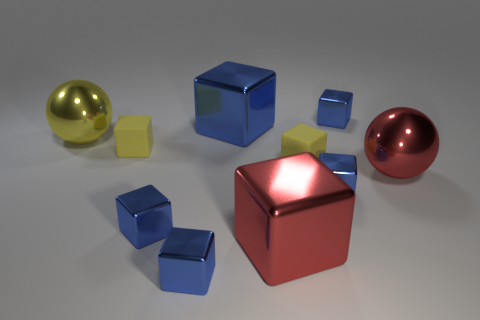How many blue cubes must be subtracted to get 1 blue cubes? 4 Subtract all tiny yellow cubes. How many cubes are left? 6 Subtract all balls. How many objects are left? 8 Subtract all blue blocks. How many blocks are left? 3 Subtract 8 cubes. How many cubes are left? 0 Subtract all purple spheres. How many gray cubes are left? 0 Subtract 1 yellow balls. How many objects are left? 9 Subtract all blue balls. Subtract all blue blocks. How many balls are left? 2 Subtract all small green rubber cubes. Subtract all big shiny things. How many objects are left? 6 Add 4 large yellow things. How many large yellow things are left? 5 